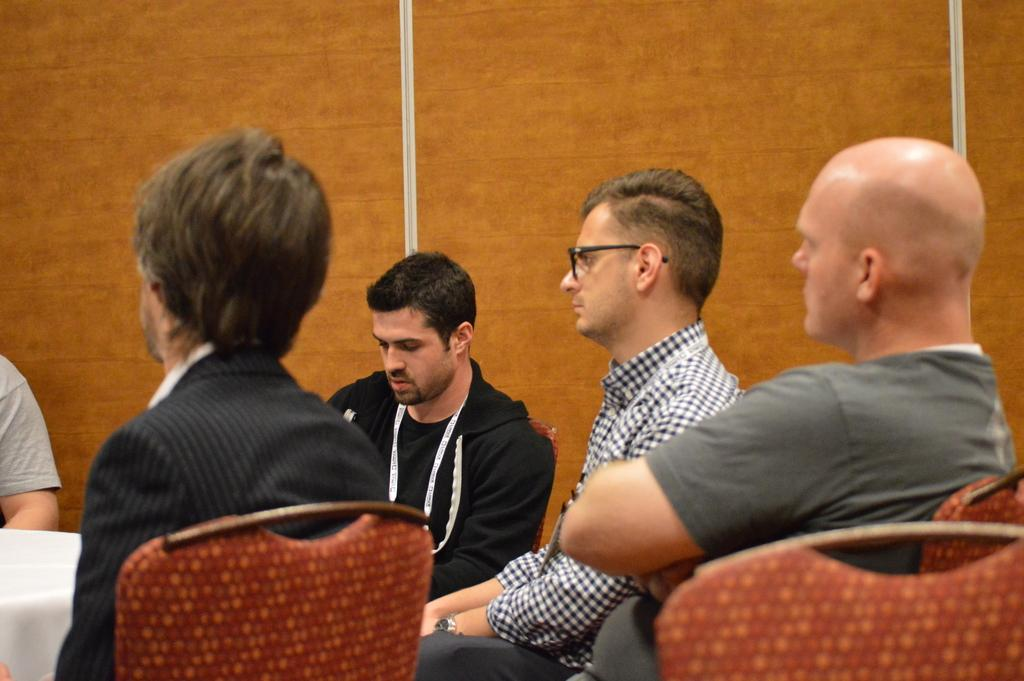Who or what is present in the image? There are people in the image. What type of furniture is visible in the image? There are chairs and a table in the image. What can be seen in the background of the image? The background of the image is a well. How does the wind affect the alley in the image? There is no alley present in the image, and therefore no wind can be observed affecting it. 